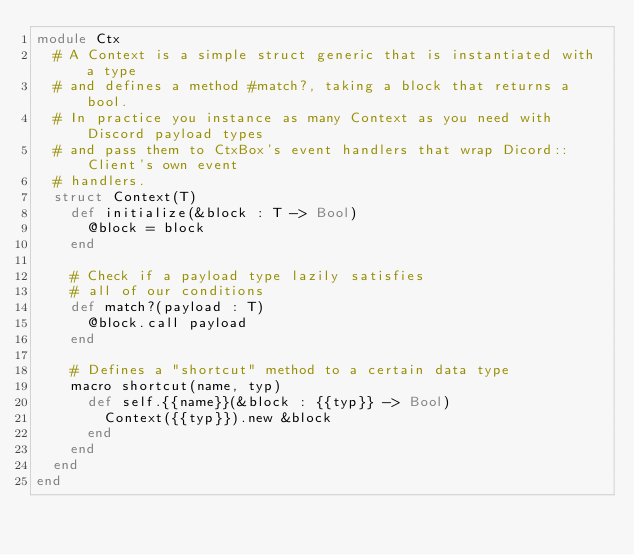Convert code to text. <code><loc_0><loc_0><loc_500><loc_500><_Crystal_>module Ctx
  # A Context is a simple struct generic that is instantiated with a type
  # and defines a method #match?, taking a block that returns a bool.
  # In practice you instance as many Context as you need with Discord payload types
  # and pass them to CtxBox's event handlers that wrap Dicord::Client's own event
  # handlers.
  struct Context(T)
    def initialize(&block : T -> Bool)
      @block = block
    end

    # Check if a payload type lazily satisfies
    # all of our conditions
    def match?(payload : T)
      @block.call payload
    end

    # Defines a "shortcut" method to a certain data type
    macro shortcut(name, typ)
      def self.{{name}}(&block : {{typ}} -> Bool)
        Context({{typ}}).new &block
      end
    end
  end
end
</code> 